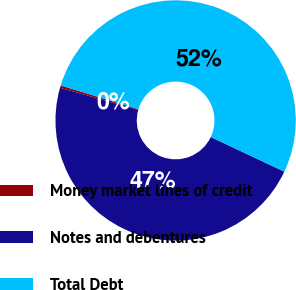<chart> <loc_0><loc_0><loc_500><loc_500><pie_chart><fcel>Money market lines of credit<fcel>Notes and debentures<fcel>Total Debt<nl><fcel>0.32%<fcel>47.38%<fcel>52.29%<nl></chart> 